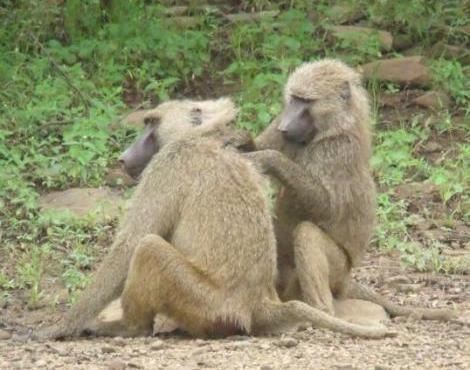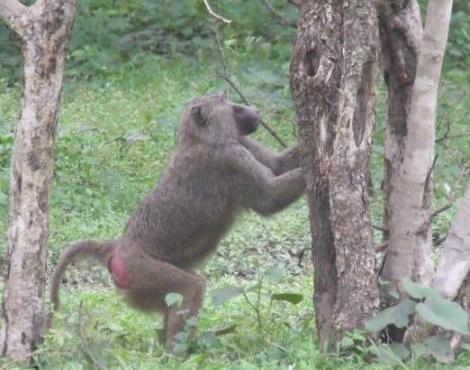The first image is the image on the left, the second image is the image on the right. Given the left and right images, does the statement "One image features a baby baboon next to an adult baboon" hold true? Answer yes or no. No. The first image is the image on the left, the second image is the image on the right. For the images displayed, is the sentence "There are exactly three monkeys" factually correct? Answer yes or no. Yes. 